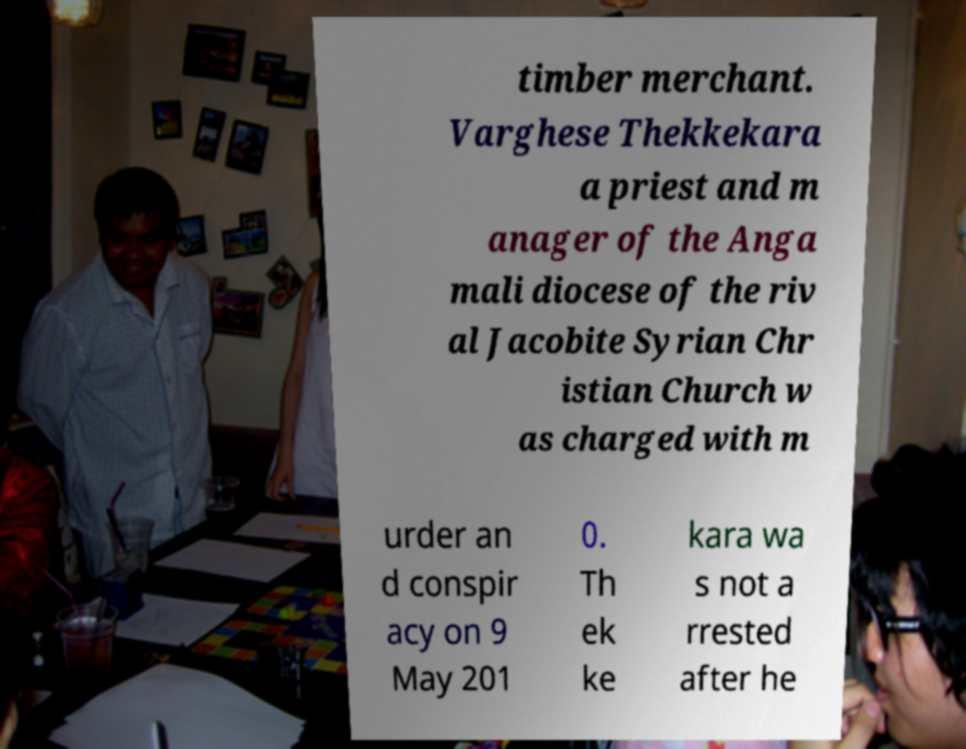Please identify and transcribe the text found in this image. timber merchant. Varghese Thekkekara a priest and m anager of the Anga mali diocese of the riv al Jacobite Syrian Chr istian Church w as charged with m urder an d conspir acy on 9 May 201 0. Th ek ke kara wa s not a rrested after he 